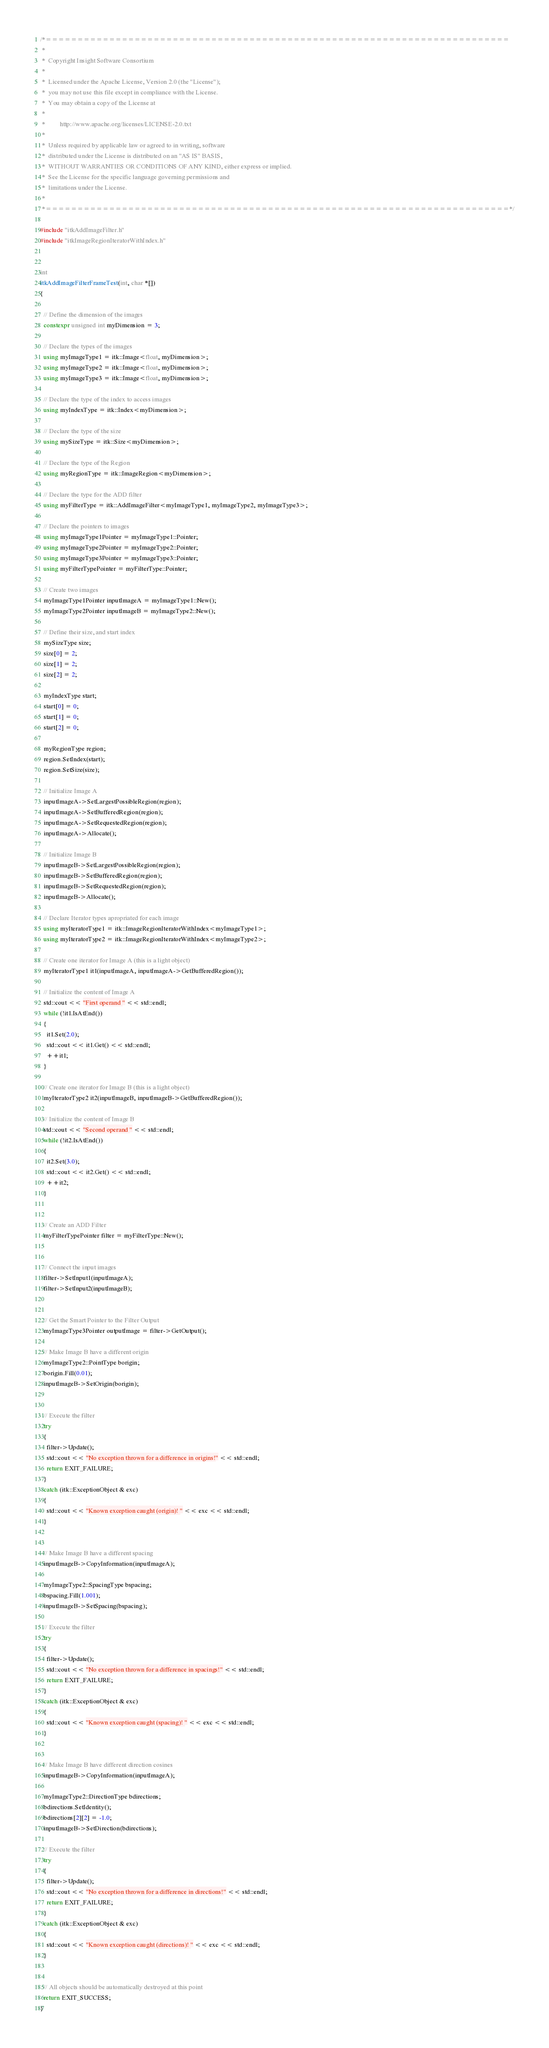Convert code to text. <code><loc_0><loc_0><loc_500><loc_500><_C++_>/*=========================================================================
 *
 *  Copyright Insight Software Consortium
 *
 *  Licensed under the Apache License, Version 2.0 (the "License");
 *  you may not use this file except in compliance with the License.
 *  You may obtain a copy of the License at
 *
 *         http://www.apache.org/licenses/LICENSE-2.0.txt
 *
 *  Unless required by applicable law or agreed to in writing, software
 *  distributed under the License is distributed on an "AS IS" BASIS,
 *  WITHOUT WARRANTIES OR CONDITIONS OF ANY KIND, either express or implied.
 *  See the License for the specific language governing permissions and
 *  limitations under the License.
 *
 *=========================================================================*/

#include "itkAddImageFilter.h"
#include "itkImageRegionIteratorWithIndex.h"


int
itkAddImageFilterFrameTest(int, char *[])
{

  // Define the dimension of the images
  constexpr unsigned int myDimension = 3;

  // Declare the types of the images
  using myImageType1 = itk::Image<float, myDimension>;
  using myImageType2 = itk::Image<float, myDimension>;
  using myImageType3 = itk::Image<float, myDimension>;

  // Declare the type of the index to access images
  using myIndexType = itk::Index<myDimension>;

  // Declare the type of the size
  using mySizeType = itk::Size<myDimension>;

  // Declare the type of the Region
  using myRegionType = itk::ImageRegion<myDimension>;

  // Declare the type for the ADD filter
  using myFilterType = itk::AddImageFilter<myImageType1, myImageType2, myImageType3>;

  // Declare the pointers to images
  using myImageType1Pointer = myImageType1::Pointer;
  using myImageType2Pointer = myImageType2::Pointer;
  using myImageType3Pointer = myImageType3::Pointer;
  using myFilterTypePointer = myFilterType::Pointer;

  // Create two images
  myImageType1Pointer inputImageA = myImageType1::New();
  myImageType2Pointer inputImageB = myImageType2::New();

  // Define their size, and start index
  mySizeType size;
  size[0] = 2;
  size[1] = 2;
  size[2] = 2;

  myIndexType start;
  start[0] = 0;
  start[1] = 0;
  start[2] = 0;

  myRegionType region;
  region.SetIndex(start);
  region.SetSize(size);

  // Initialize Image A
  inputImageA->SetLargestPossibleRegion(region);
  inputImageA->SetBufferedRegion(region);
  inputImageA->SetRequestedRegion(region);
  inputImageA->Allocate();

  // Initialize Image B
  inputImageB->SetLargestPossibleRegion(region);
  inputImageB->SetBufferedRegion(region);
  inputImageB->SetRequestedRegion(region);
  inputImageB->Allocate();

  // Declare Iterator types apropriated for each image
  using myIteratorType1 = itk::ImageRegionIteratorWithIndex<myImageType1>;
  using myIteratorType2 = itk::ImageRegionIteratorWithIndex<myImageType2>;

  // Create one iterator for Image A (this is a light object)
  myIteratorType1 it1(inputImageA, inputImageA->GetBufferedRegion());

  // Initialize the content of Image A
  std::cout << "First operand " << std::endl;
  while (!it1.IsAtEnd())
  {
    it1.Set(2.0);
    std::cout << it1.Get() << std::endl;
    ++it1;
  }

  // Create one iterator for Image B (this is a light object)
  myIteratorType2 it2(inputImageB, inputImageB->GetBufferedRegion());

  // Initialize the content of Image B
  std::cout << "Second operand " << std::endl;
  while (!it2.IsAtEnd())
  {
    it2.Set(3.0);
    std::cout << it2.Get() << std::endl;
    ++it2;
  }


  // Create an ADD Filter
  myFilterTypePointer filter = myFilterType::New();


  // Connect the input images
  filter->SetInput1(inputImageA);
  filter->SetInput2(inputImageB);


  // Get the Smart Pointer to the Filter Output
  myImageType3Pointer outputImage = filter->GetOutput();

  // Make Image B have a different origin
  myImageType2::PointType borigin;
  borigin.Fill(0.01);
  inputImageB->SetOrigin(borigin);


  // Execute the filter
  try
  {
    filter->Update();
    std::cout << "No exception thrown for a difference in origins!" << std::endl;
    return EXIT_FAILURE;
  }
  catch (itk::ExceptionObject & exc)
  {
    std::cout << "Known exception caught (origin)! " << exc << std::endl;
  }


  // Make Image B have a different spacing
  inputImageB->CopyInformation(inputImageA);

  myImageType2::SpacingType bspacing;
  bspacing.Fill(1.001);
  inputImageB->SetSpacing(bspacing);

  // Execute the filter
  try
  {
    filter->Update();
    std::cout << "No exception thrown for a difference in spacings!" << std::endl;
    return EXIT_FAILURE;
  }
  catch (itk::ExceptionObject & exc)
  {
    std::cout << "Known exception caught (spacing)! " << exc << std::endl;
  }


  // Make Image B have different direction cosines
  inputImageB->CopyInformation(inputImageA);

  myImageType2::DirectionType bdirections;
  bdirections.SetIdentity();
  bdirections[2][2] = -1.0;
  inputImageB->SetDirection(bdirections);

  // Execute the filter
  try
  {
    filter->Update();
    std::cout << "No exception thrown for a difference in directions!" << std::endl;
    return EXIT_FAILURE;
  }
  catch (itk::ExceptionObject & exc)
  {
    std::cout << "Known exception caught (directions)! " << exc << std::endl;
  }


  // All objects should be automatically destroyed at this point
  return EXIT_SUCCESS;
}
</code> 